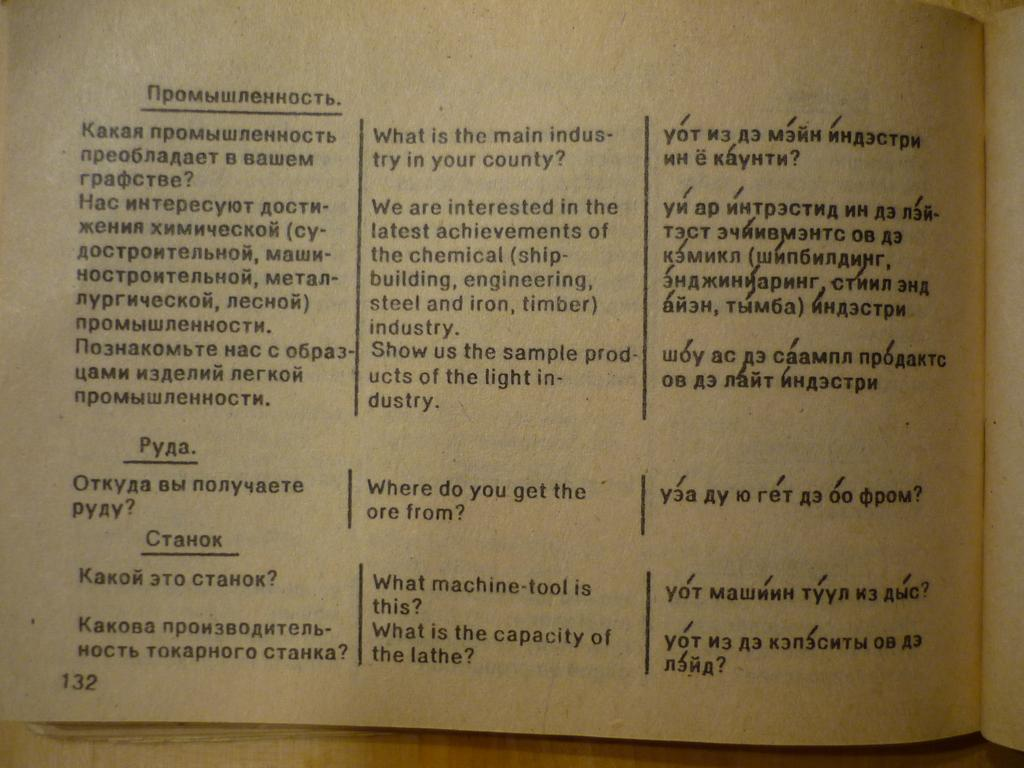<image>
Write a terse but informative summary of the picture. Open book with the page 132 on the bottom left. 